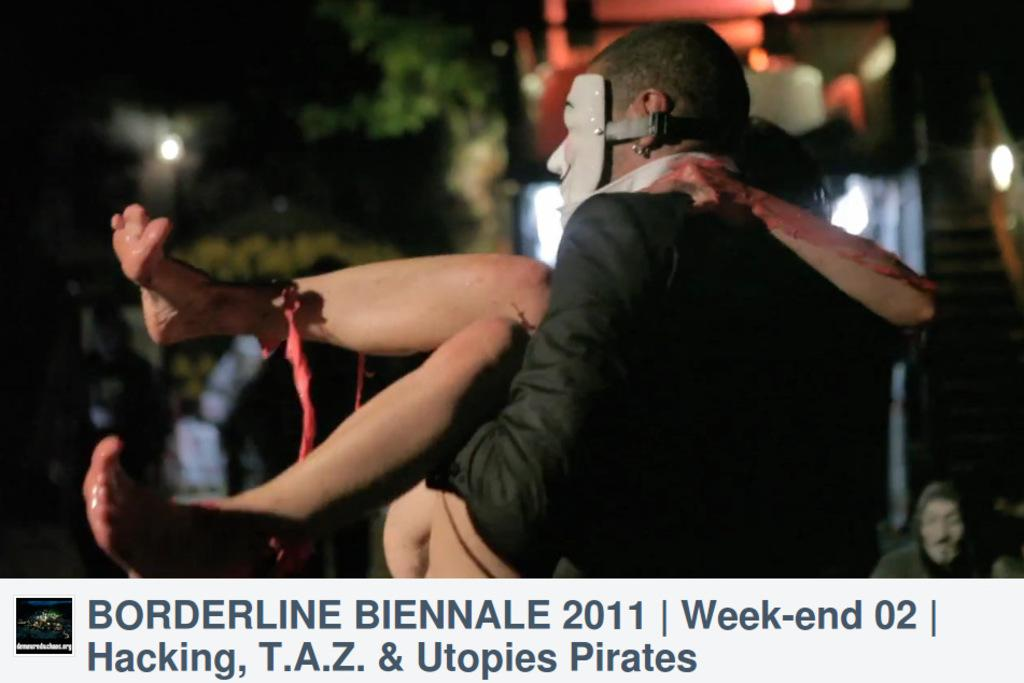Who is the main subject in the image? There is a man in the image. What is the man wearing on his face? The man is wearing a mask on his face. What is the man doing in the image? The man is carrying a woman. What can be seen in the background of the image? There are trees and a building in the background of the image. What type of airplane can be seen in the background of the image? There is no airplane visible in the background of the image; it only features trees and a building. What yard-related activities are taking place in the image? There is no yard or yard-related activities present in the image. 